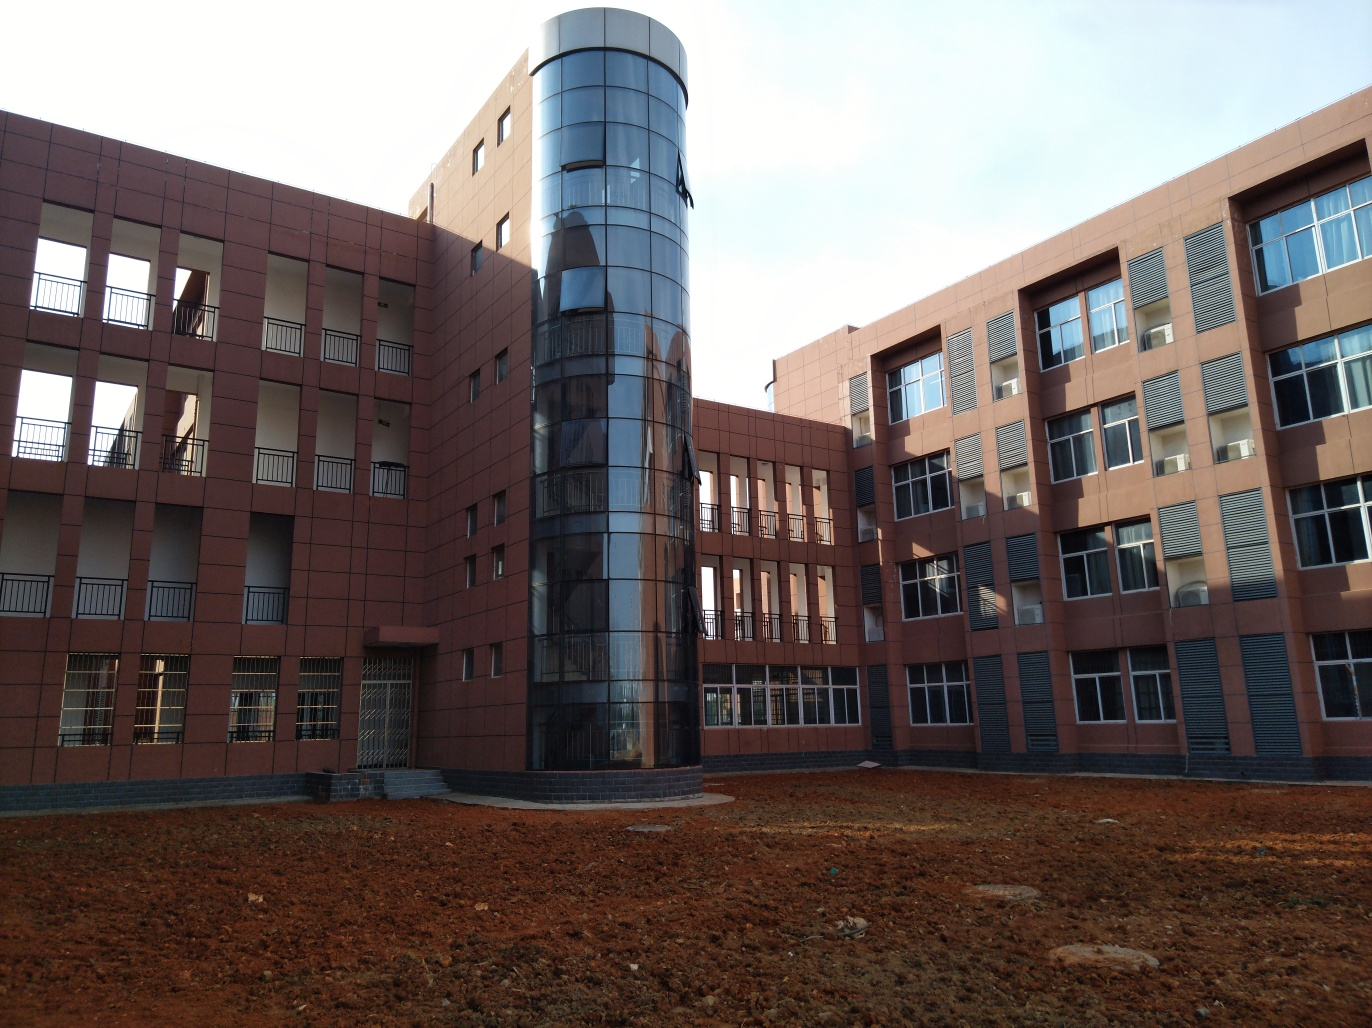What is this building likely used for? Given the structured design and multiple floors with regularly spaced windows, it's likely that this building serves an institutional or commercial purpose, such as university facilities, office spaces, or possibly a governmental structure. 